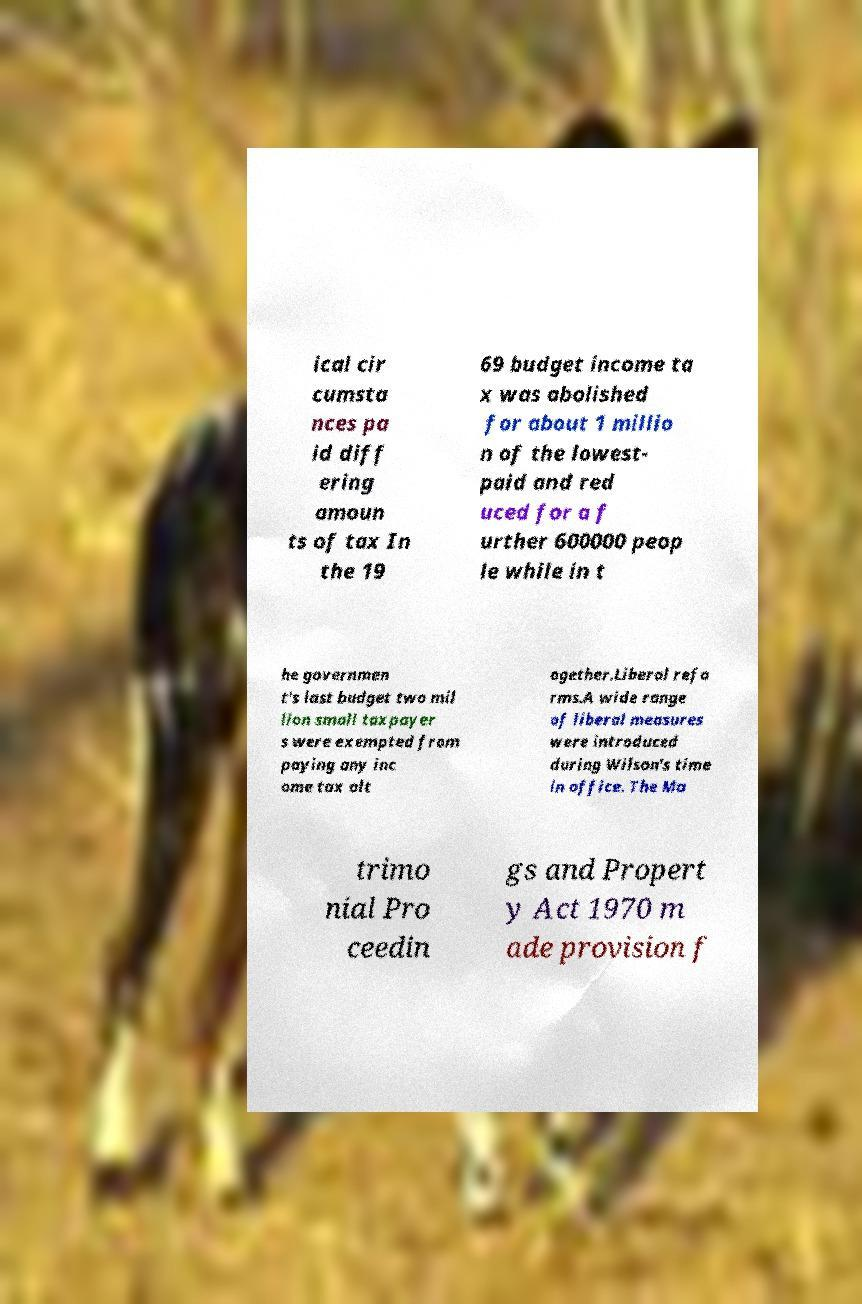Can you accurately transcribe the text from the provided image for me? ical cir cumsta nces pa id diff ering amoun ts of tax In the 19 69 budget income ta x was abolished for about 1 millio n of the lowest- paid and red uced for a f urther 600000 peop le while in t he governmen t's last budget two mil lion small taxpayer s were exempted from paying any inc ome tax alt ogether.Liberal refo rms.A wide range of liberal measures were introduced during Wilson's time in office. The Ma trimo nial Pro ceedin gs and Propert y Act 1970 m ade provision f 